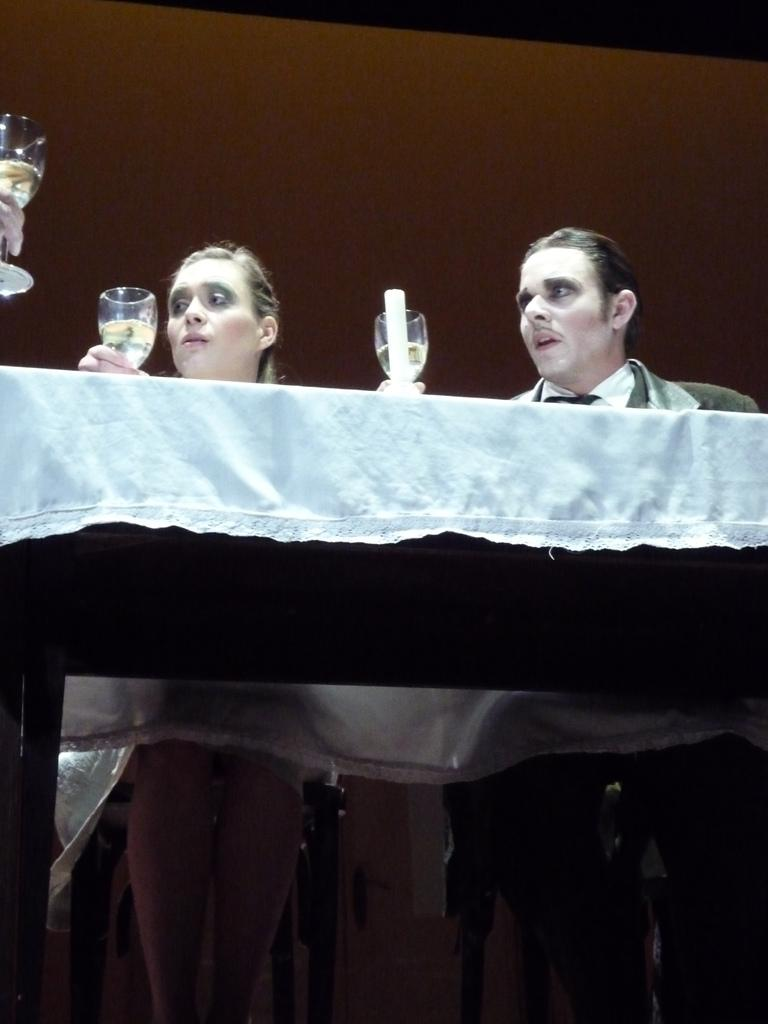Who is present in the image? There is a woman and a man in the image. What are the woman and the man doing in the image? The woman and the man are sitting on chairs in the image. What objects are in front of them? There is a table in front of the woman and the man. What are they holding in their hands? The woman and the man are holding glasses in their hands. What can be seen on the table? There is a candle on the table. What type of cart is being used to transport the woman and the man in the image? There is no cart present in the image; the woman and the man are sitting on chairs. What kind of party is being held in the image? There is no indication of a party in the image; it simply shows a woman and a man sitting on chairs with a table and candle. 